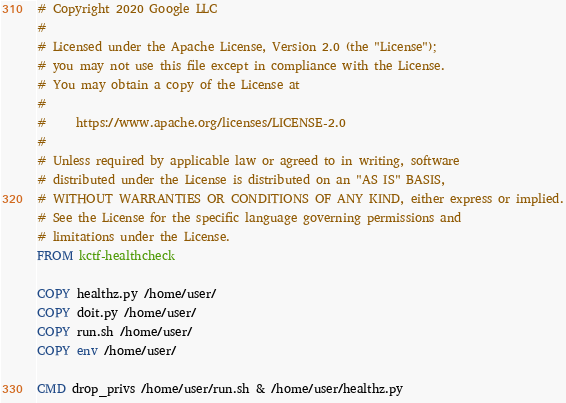<code> <loc_0><loc_0><loc_500><loc_500><_Dockerfile_># Copyright 2020 Google LLC
# 
# Licensed under the Apache License, Version 2.0 (the "License");
# you may not use this file except in compliance with the License.
# You may obtain a copy of the License at
# 
#     https://www.apache.org/licenses/LICENSE-2.0
# 
# Unless required by applicable law or agreed to in writing, software
# distributed under the License is distributed on an "AS IS" BASIS,
# WITHOUT WARRANTIES OR CONDITIONS OF ANY KIND, either express or implied.
# See the License for the specific language governing permissions and
# limitations under the License.
FROM kctf-healthcheck

COPY healthz.py /home/user/
COPY doit.py /home/user/
COPY run.sh /home/user/
COPY env /home/user/

CMD drop_privs /home/user/run.sh & /home/user/healthz.py
</code> 